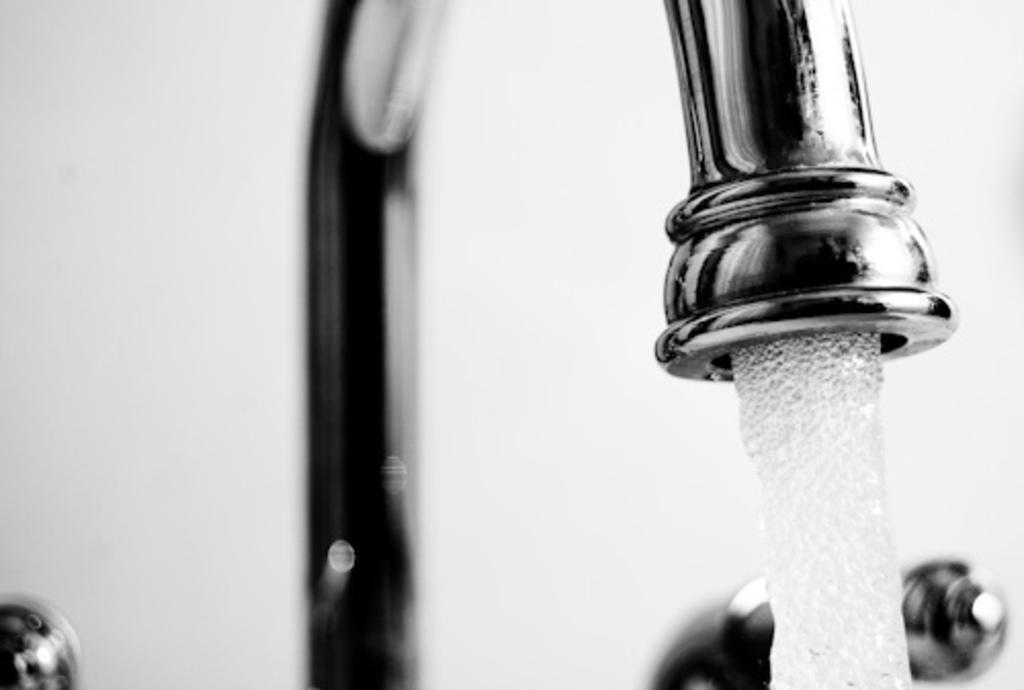How would you summarize this image in a sentence or two? This is a black and white image where we can see water coming through a tap and in the background, there is a wall. 